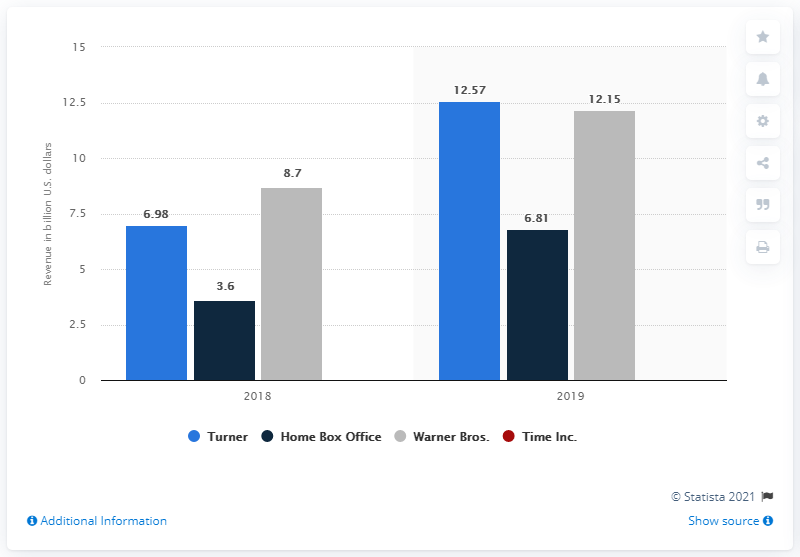Indicate a few pertinent items in this graphic. WarnerMedia generated a total revenue of 12.15 billion US dollars in 2021 through its subsidiary, Warner Bros. Turner's revenue in 2020 was 12.57 million. In 2020, WarnerMedia generated a total revenue of 12.15 billion US dollars. 